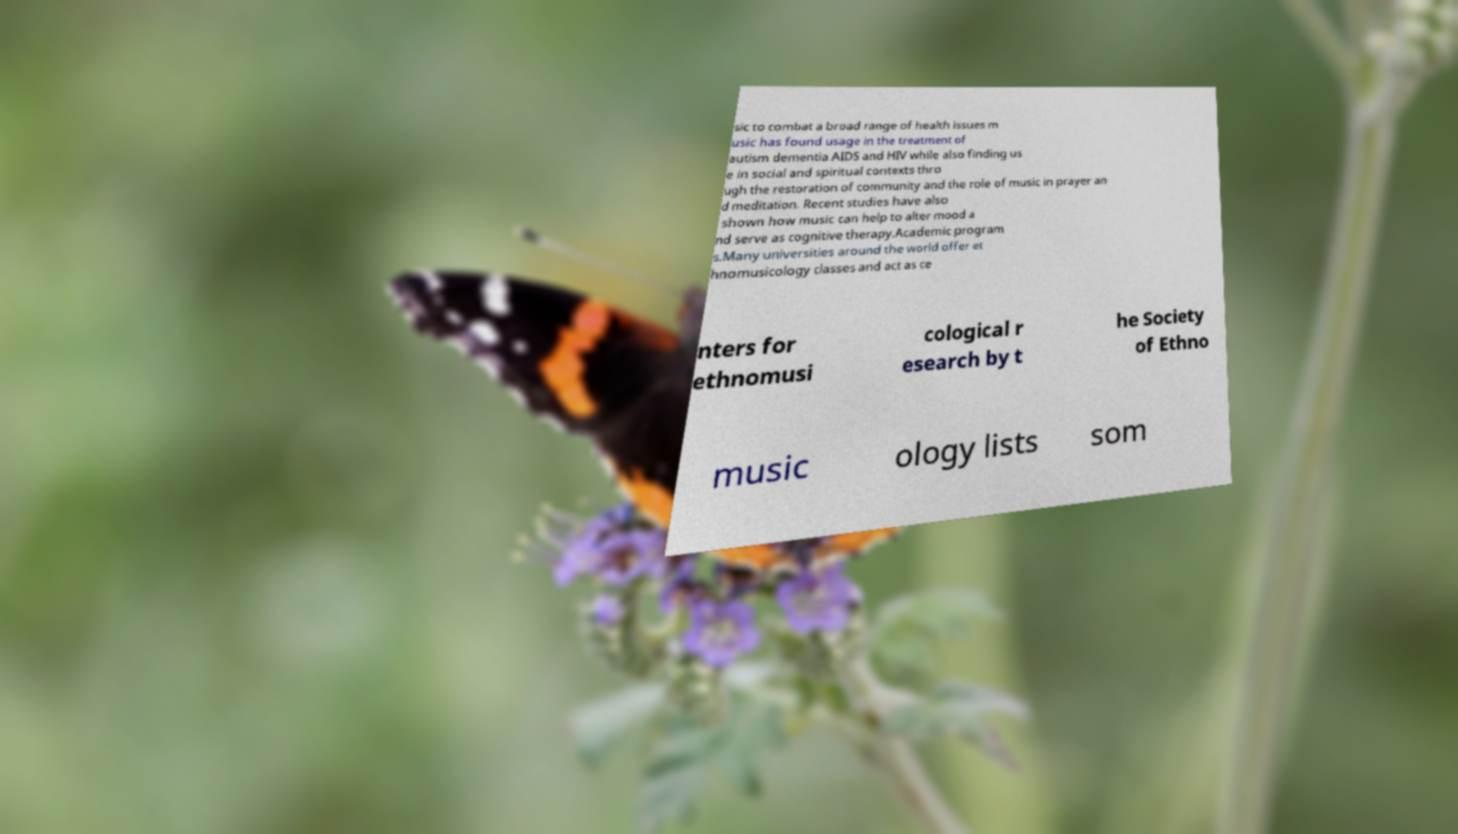What messages or text are displayed in this image? I need them in a readable, typed format. sic to combat a broad range of health issues m usic has found usage in the treatment of autism dementia AIDS and HIV while also finding us e in social and spiritual contexts thro ugh the restoration of community and the role of music in prayer an d meditation. Recent studies have also shown how music can help to alter mood a nd serve as cognitive therapy.Academic program s.Many universities around the world offer et hnomusicology classes and act as ce nters for ethnomusi cological r esearch by t he Society of Ethno music ology lists som 